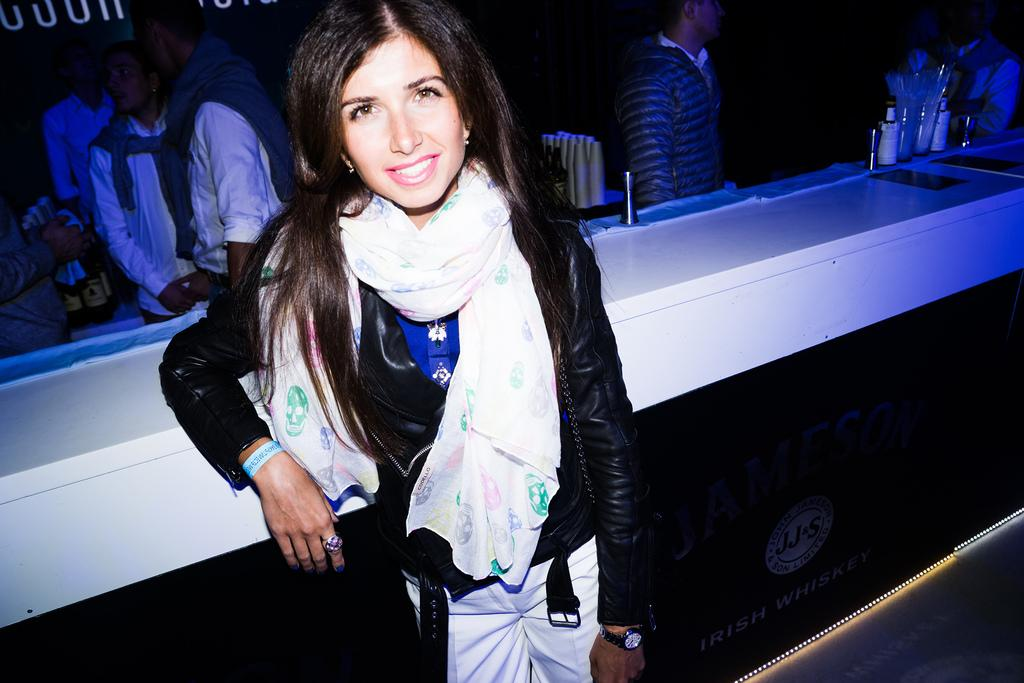Who is the main subject in the foreground of the image? There is a woman in the foreground of the image. What can be seen in the background of the image? There are many people in the background of the image. What type of furniture is present in the image? There is a counter table in the image. How would you describe the lighting in the image? The background of the image is dark. What type of cub is interacting with the woman in the image? There is no cub present in the image, so it cannot be interacting with the woman. 